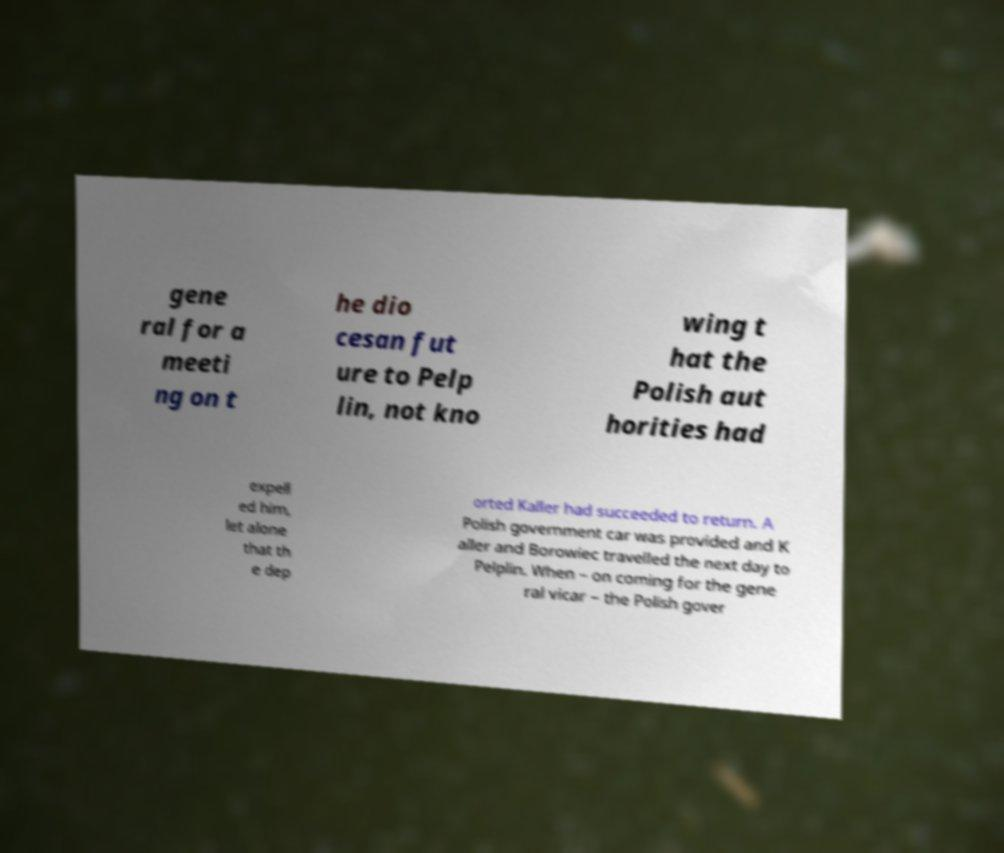Could you assist in decoding the text presented in this image and type it out clearly? gene ral for a meeti ng on t he dio cesan fut ure to Pelp lin, not kno wing t hat the Polish aut horities had expell ed him, let alone that th e dep orted Kaller had succeeded to return. A Polish government car was provided and K aller and Borowiec travelled the next day to Pelplin. When – on coming for the gene ral vicar – the Polish gover 